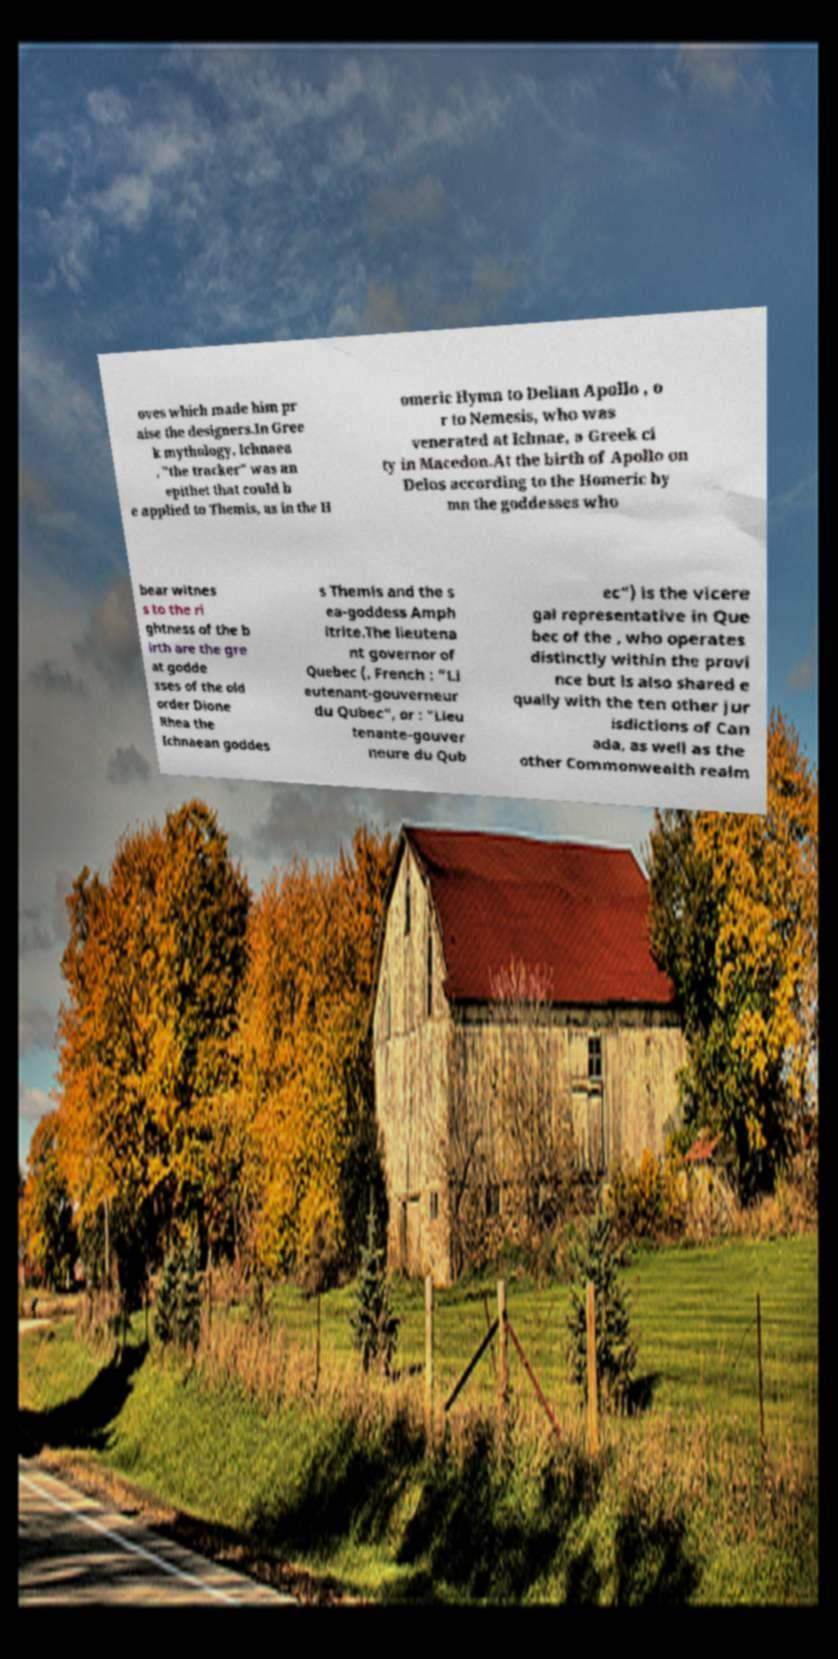What messages or text are displayed in this image? I need them in a readable, typed format. oves which made him pr aise the designers.In Gree k mythology, Ichnaea , "the tracker" was an epithet that could b e applied to Themis, as in the H omeric Hymn to Delian Apollo , o r to Nemesis, who was venerated at Ichnae, a Greek ci ty in Macedon.At the birth of Apollo on Delos according to the Homeric hy mn the goddesses who bear witnes s to the ri ghtness of the b irth are the gre at godde sses of the old order Dione Rhea the Ichnaean goddes s Themis and the s ea-goddess Amph itrite.The lieutena nt governor of Quebec (, French : "Li eutenant-gouverneur du Qubec", or : "Lieu tenante-gouver neure du Qub ec") is the vicere gal representative in Que bec of the , who operates distinctly within the provi nce but is also shared e qually with the ten other jur isdictions of Can ada, as well as the other Commonwealth realm 